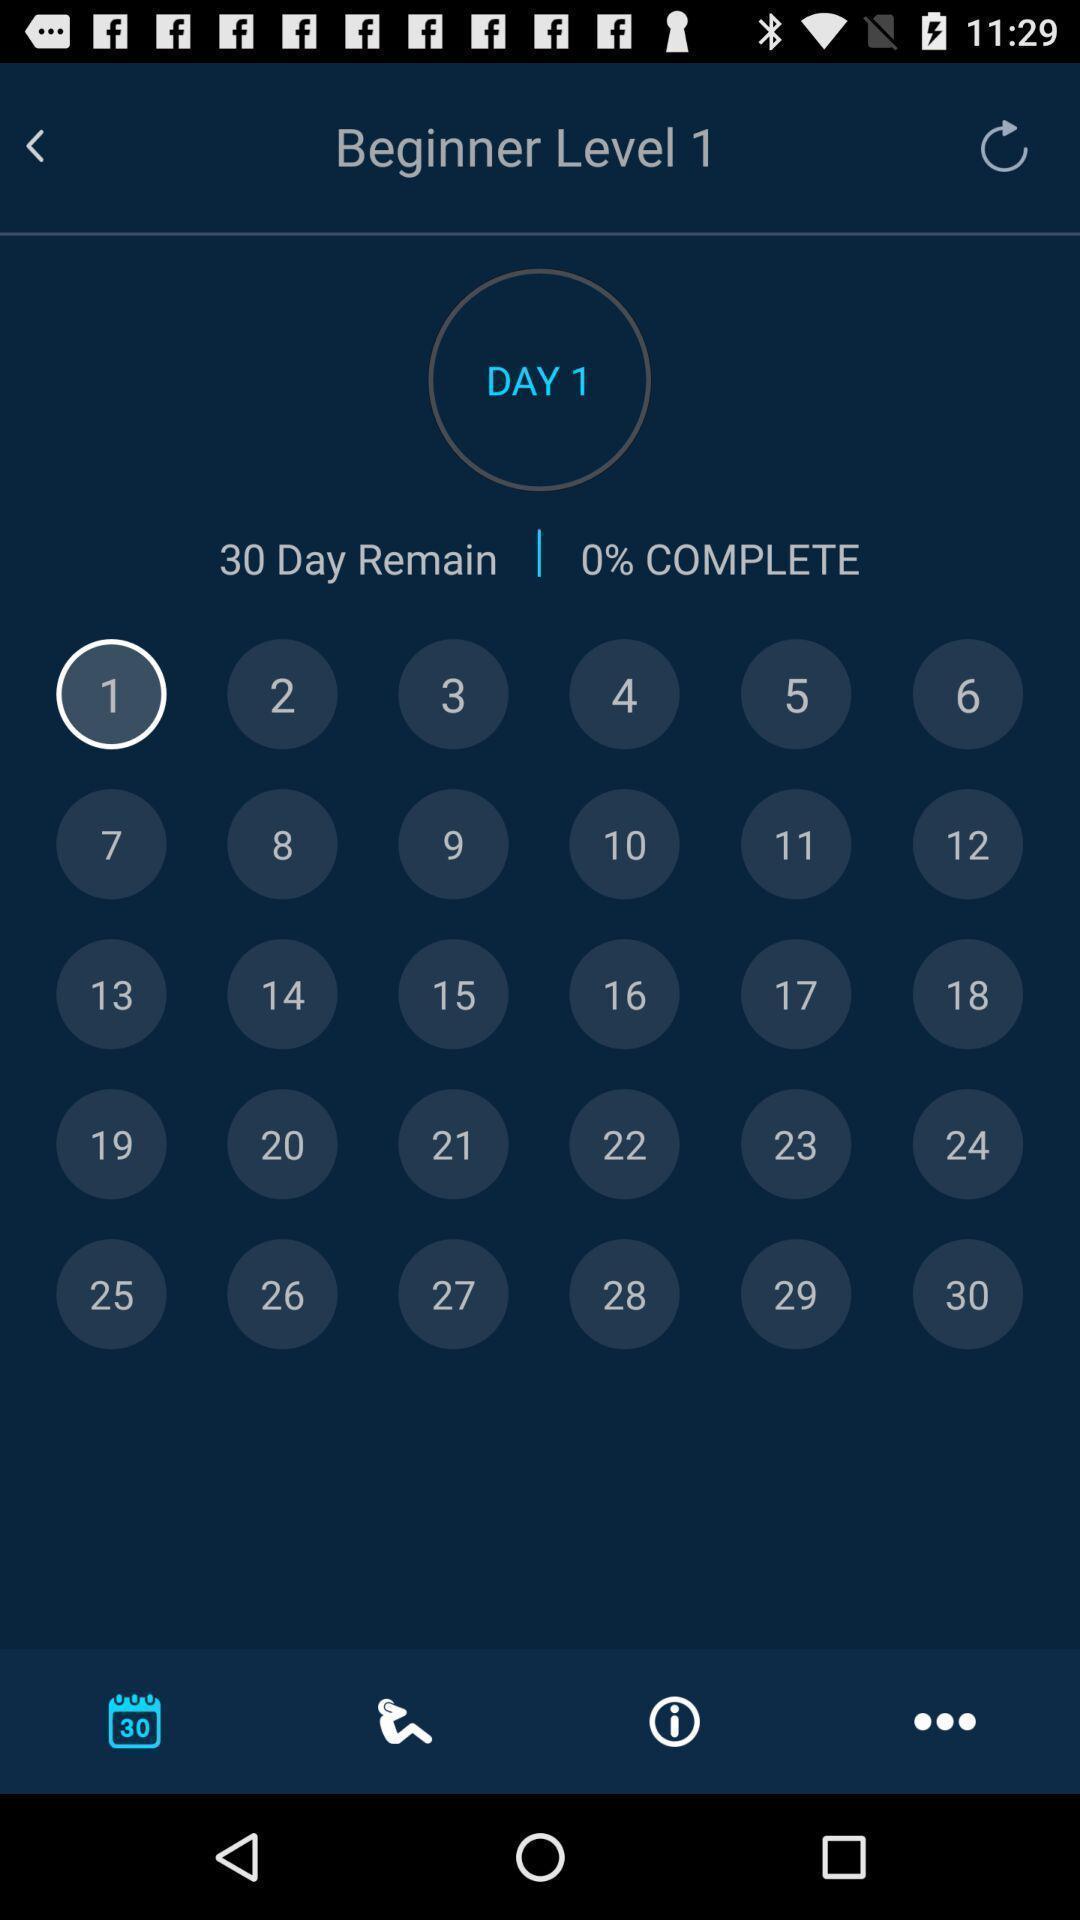What can you discern from this picture? Page showing calendar. 